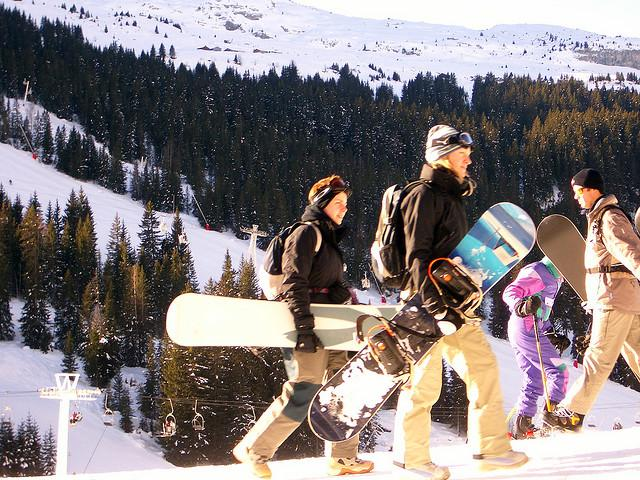What are these people in the front carrying? snowboards 